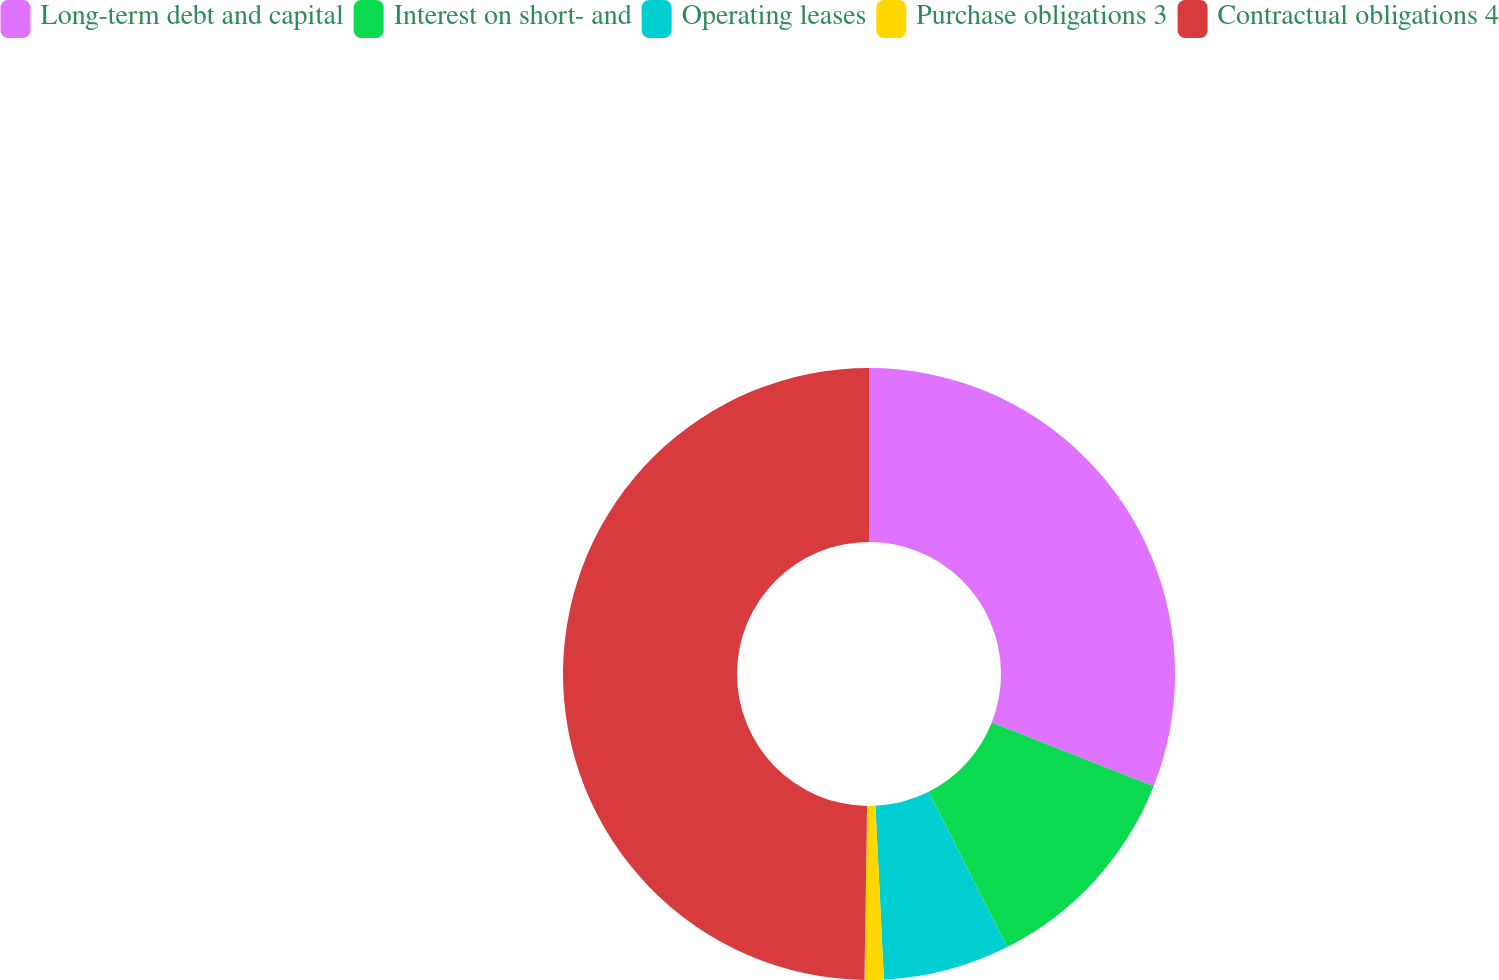Convert chart to OTSL. <chart><loc_0><loc_0><loc_500><loc_500><pie_chart><fcel>Long-term debt and capital<fcel>Interest on short- and<fcel>Operating leases<fcel>Purchase obligations 3<fcel>Contractual obligations 4<nl><fcel>30.98%<fcel>11.56%<fcel>6.68%<fcel>1.01%<fcel>49.76%<nl></chart> 